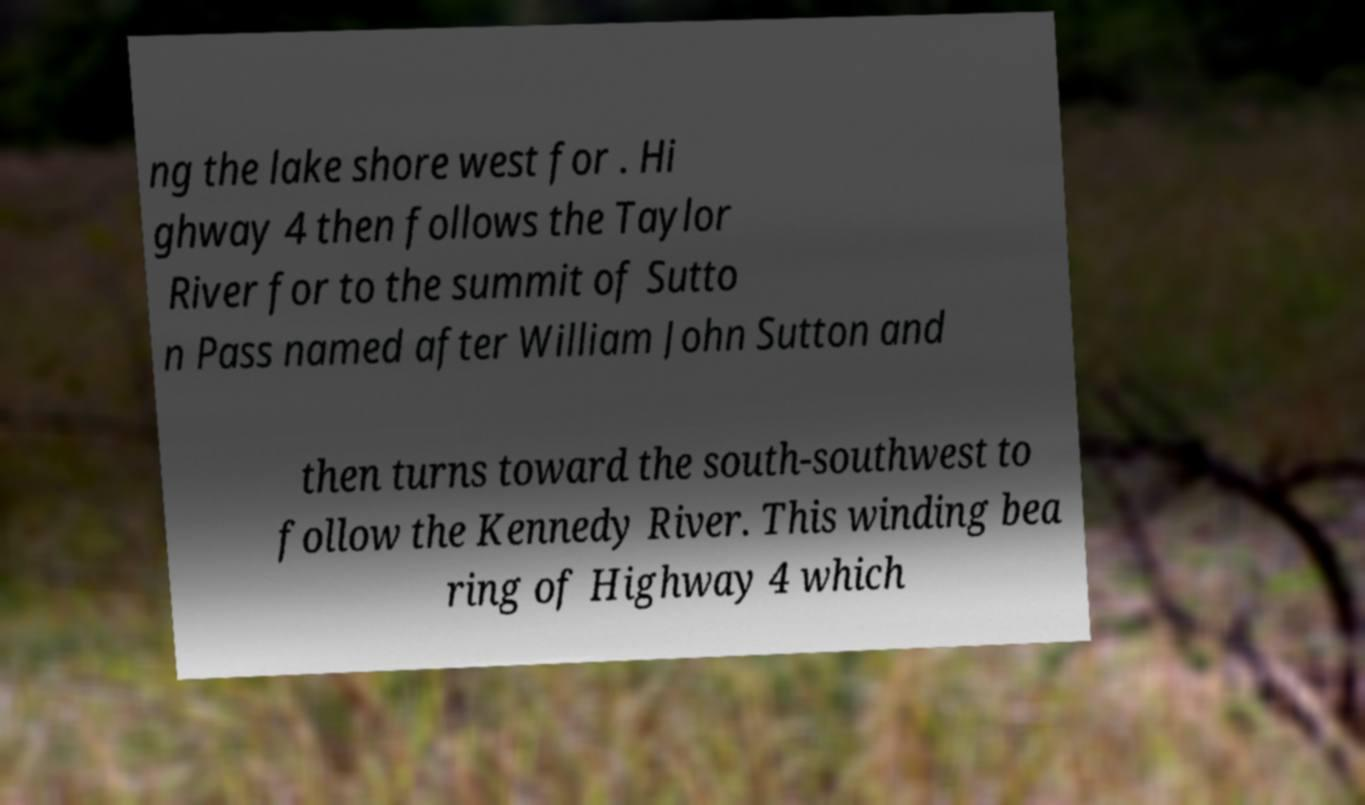What messages or text are displayed in this image? I need them in a readable, typed format. ng the lake shore west for . Hi ghway 4 then follows the Taylor River for to the summit of Sutto n Pass named after William John Sutton and then turns toward the south-southwest to follow the Kennedy River. This winding bea ring of Highway 4 which 